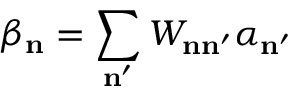Convert formula to latex. <formula><loc_0><loc_0><loc_500><loc_500>\beta _ { n } = \sum _ { n ^ { \prime } } W _ { n n ^ { \prime } } \alpha _ { n ^ { \prime } }</formula> 